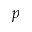Convert formula to latex. <formula><loc_0><loc_0><loc_500><loc_500>p</formula> 